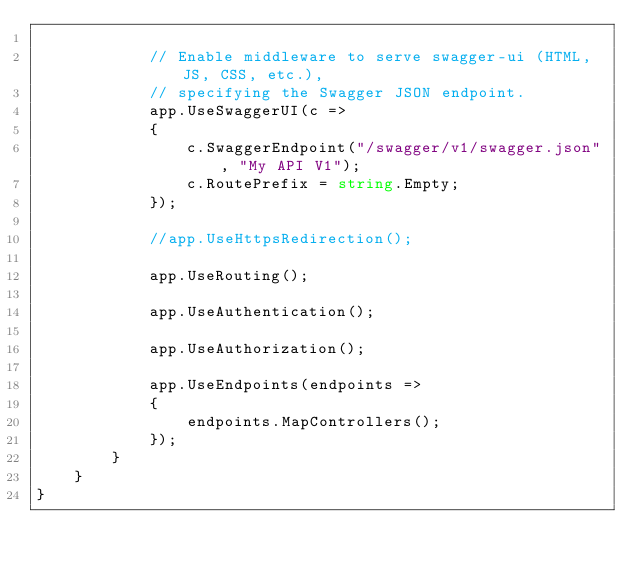Convert code to text. <code><loc_0><loc_0><loc_500><loc_500><_C#_>
            // Enable middleware to serve swagger-ui (HTML, JS, CSS, etc.),
            // specifying the Swagger JSON endpoint.
            app.UseSwaggerUI(c =>
            {
                c.SwaggerEndpoint("/swagger/v1/swagger.json", "My API V1");
                c.RoutePrefix = string.Empty;
            });

            //app.UseHttpsRedirection();

            app.UseRouting();

            app.UseAuthentication();

            app.UseAuthorization();

            app.UseEndpoints(endpoints =>
            {
                endpoints.MapControllers();
            });
        }
    }
}
</code> 